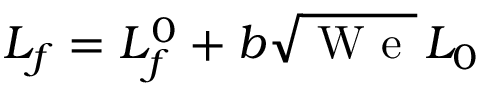Convert formula to latex. <formula><loc_0><loc_0><loc_500><loc_500>L _ { f } = L _ { f } ^ { 0 } + b \sqrt { W e } \, L _ { 0 }</formula> 